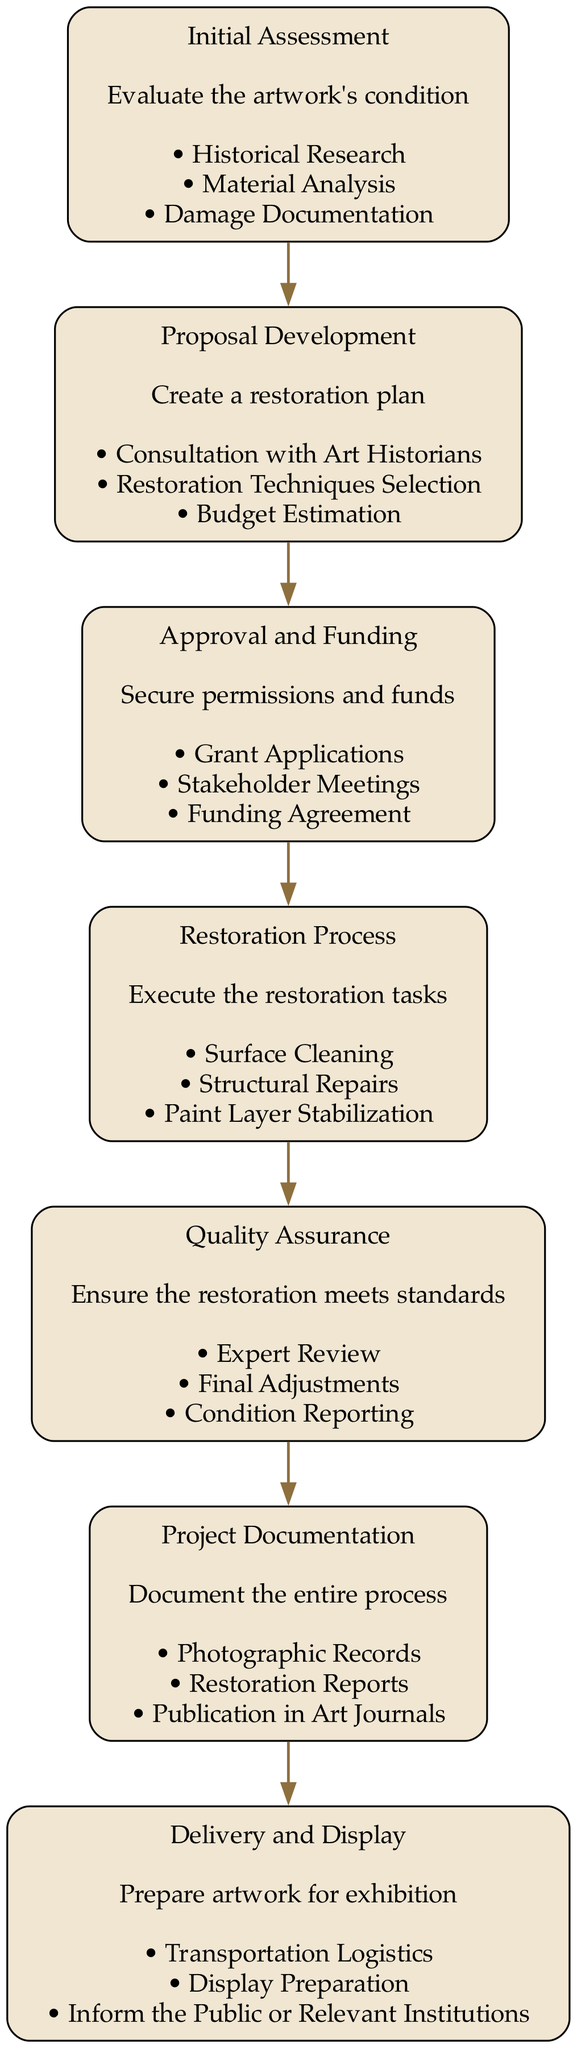What is the first step in the art restoration process? The first step is "Initial Assessment", which evaluates the artwork's condition. This can be seen as the top node in the diagram, indicating it is the starting point of the flow.
Answer: Initial Assessment How many tasks are involved in the Proposal Development stage? The "Proposal Development" stage includes three tasks: "Consultation with Art Historians," "Restoration Techniques Selection," and "Budget Estimation." Each task is listed under this node in the diagram.
Answer: Three What node follows the Approval and Funding stage? Following the "Approval and Funding" stage, the next node is the "Restoration Process." This can be confirmed by tracing the arrows in the flowchart, which connect these stages in sequence.
Answer: Restoration Process Which stage includes the task of "Expert Review"? The task "Expert Review" is included in the "Quality Assurance" stage. This can be determined by checking the listed tasks under this specific node in the diagram.
Answer: Quality Assurance What is the total number of nodes in the flowchart? The flowchart contains seven nodes detailing each stage of the restoration process, which can be counted from the diagram's elements.
Answer: Seven What is the last step in the artwork restoration process? The last step is "Delivery and Display," which prepares the artwork for exhibition. This is located at the bottom of the flowchart, indicating it's the final stage.
Answer: Delivery and Display What type of documentation is included in the Project Documentation stage? In the "Project Documentation" stage, the documentation includes "Photographic Records," "Restoration Reports," and "Publication in Art Journals." This information can be found listed under the corresponding node in the diagram.
Answer: Photographic Records, Restoration Reports, Publication in Art Journals What step requires securing permissions and funds? The step that requires securing permissions and funds is "Approval and Funding." This is evident as it explicitly outlines the need for financial and legal approval to proceed in the restoration process.
Answer: Approval and Funding Which step precedes the Quality Assurance stage? The step that precedes "Quality Assurance" is "Restoration Process." This can be verified by following the flow from node to node in the sequence.
Answer: Restoration Process 